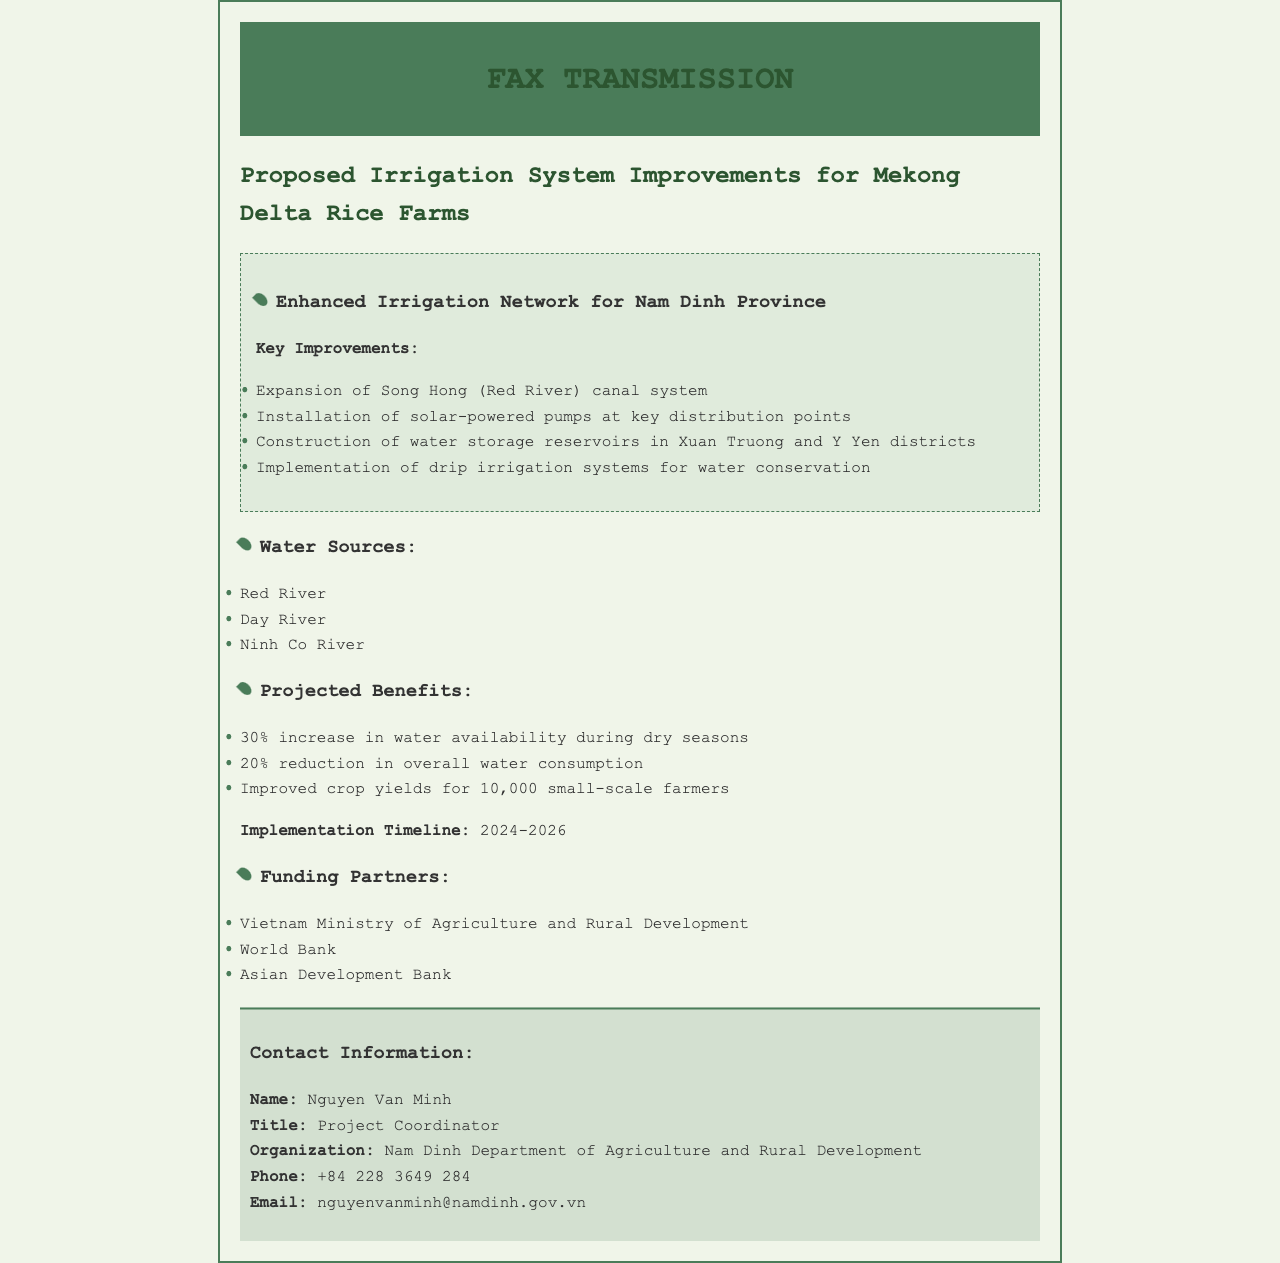What are the key improvements proposed? The key improvements include the expansion of the canal system, installation of pumps, construction of reservoirs, and implementation of drip irrigation.
Answer: Expansion of Song Hong (Red River) canal system, Installation of solar-powered pumps at key distribution points, Construction of water storage reservoirs in Xuan Truong and Y Yen districts, Implementation of drip irrigation systems for water conservation What is the projected increase in water availability during dry seasons? The document states that the projected increase in water availability during dry seasons is 30%.
Answer: 30% What is the implementation timeline for the proposed improvements? The document specifies that the implementation timeline is from 2024 to 2026.
Answer: 2024-2026 Who is the project coordinator? The project coordinator's name is mentioned in the contact information section of the document.
Answer: Nguyen Van Minh Which organization is associated with the project? The Nam Dinh Department of Agriculture and Rural Development is the organization associated with the project.
Answer: Nam Dinh Department of Agriculture and Rural Development What are the funding partners mentioned? The document lists specific organizations that are contributing funding.
Answer: Vietnam Ministry of Agriculture and Rural Development, World Bank, Asian Development Bank What is the expected reduction in overall water consumption? The document indicates the expected reduction in overall water consumption is 20%.
Answer: 20% What is the number of farmers expected to benefit? The document states that 10,000 small-scale farmers are expected to benefit from the project.
Answer: 10,000 